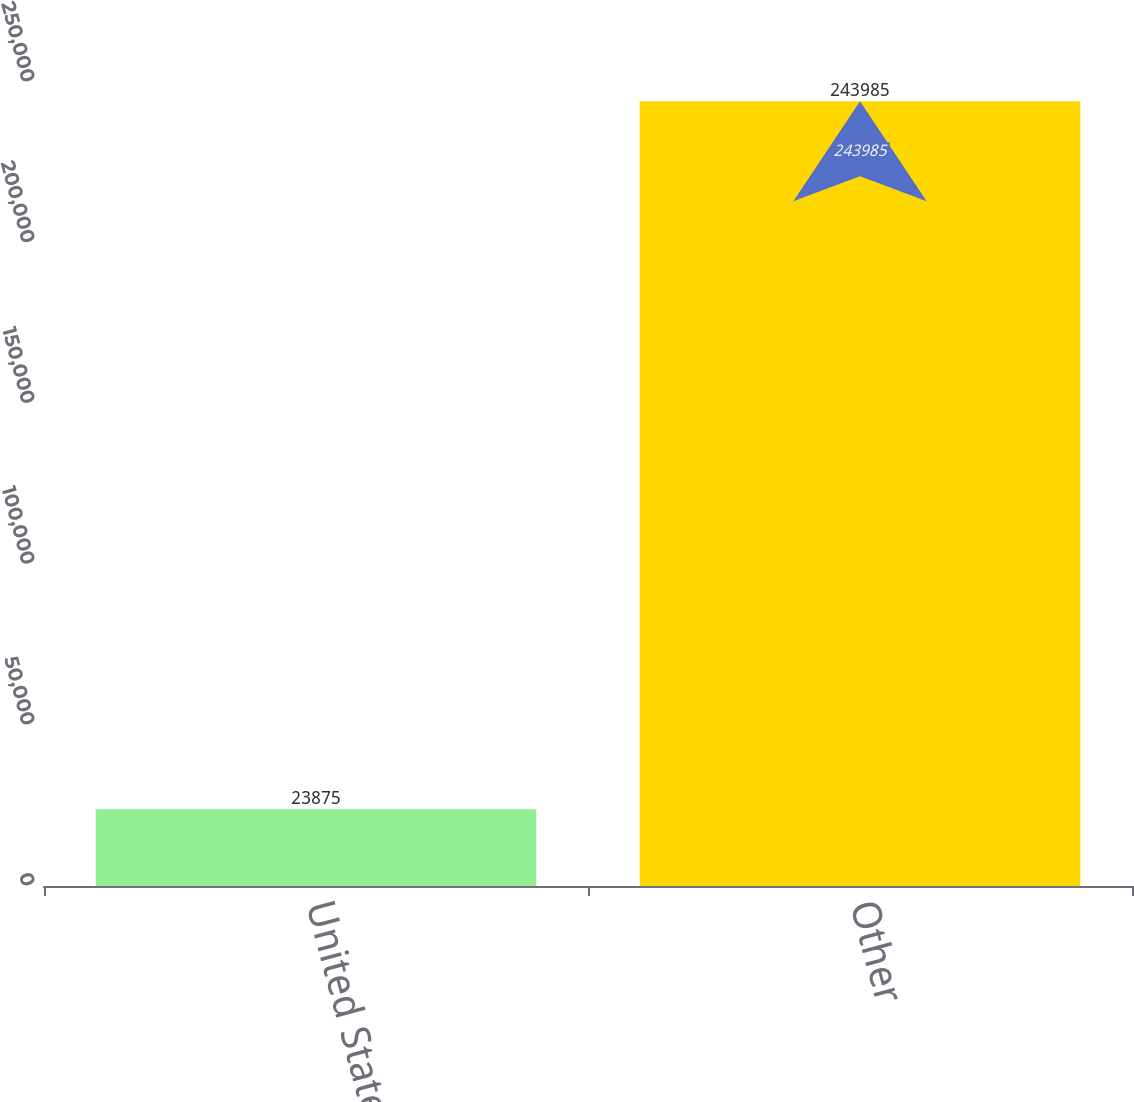<chart> <loc_0><loc_0><loc_500><loc_500><bar_chart><fcel>United States<fcel>Other<nl><fcel>23875<fcel>243985<nl></chart> 